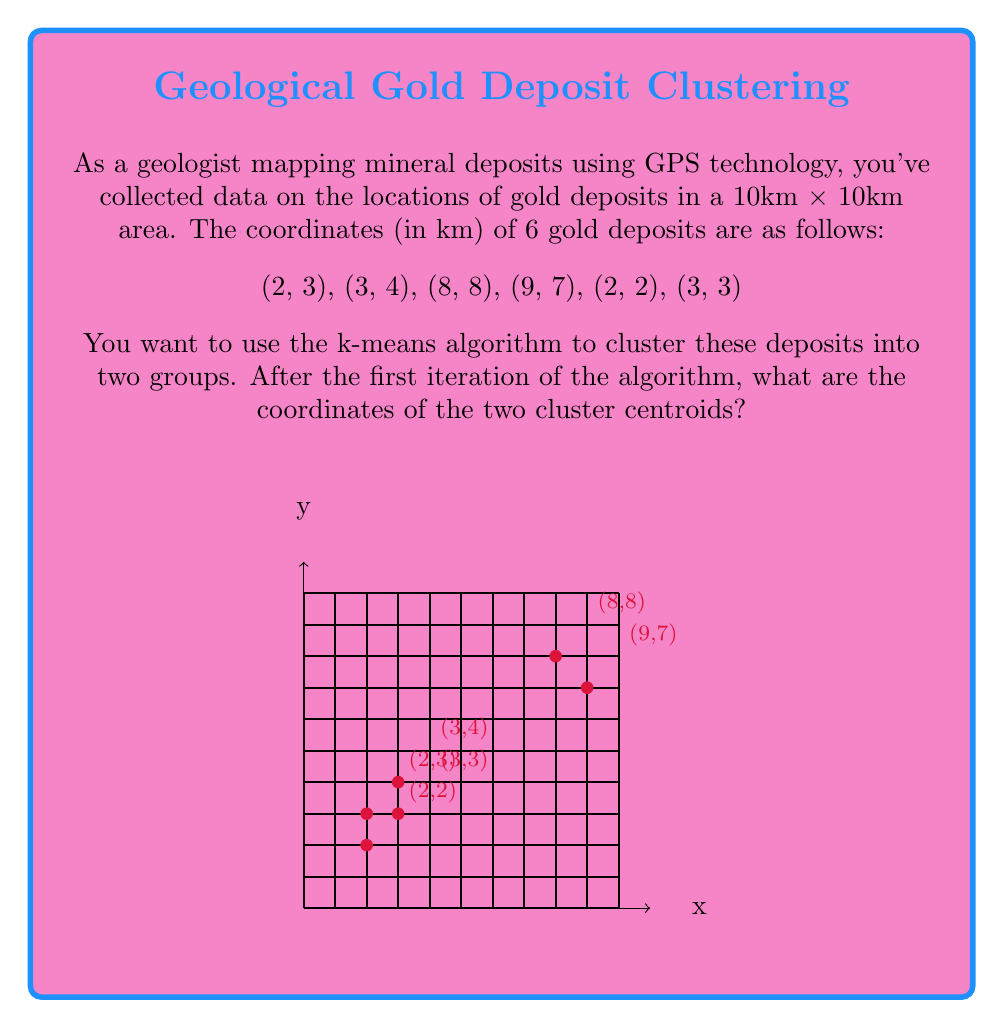Give your solution to this math problem. To solve this problem, we'll follow these steps:

1) In k-means clustering with k=2, we need to start with two initial centroids. Let's choose the first two points as our initial centroids:
   Centroid 1: (2, 3)
   Centroid 2: (3, 4)

2) Now, we need to assign each point to the nearest centroid. We'll use Euclidean distance:
   $$d = \sqrt{(x_2-x_1)^2 + (y_2-y_1)^2}$$

3) For each point, calculate the distance to both centroids:

   (2, 3): Already Centroid 1
   (3, 4): Already Centroid 2
   (8, 8): 
      To C1: $$\sqrt{(8-2)^2 + (8-3)^2} = \sqrt{61} \approx 7.81$$
      To C2: $$\sqrt{(8-3)^2 + (8-4)^2} = \sqrt{50} \approx 7.07$$ (Closer to C2)
   (9, 7):
      To C1: $$\sqrt{(9-2)^2 + (7-3)^2} = \sqrt{85} \approx 9.22$$
      To C2: $$\sqrt{(9-3)^2 + (7-4)^2} = \sqrt{61} \approx 7.81$$ (Closer to C2)
   (2, 2):
      To C1: $$\sqrt{(2-2)^2 + (2-3)^2} = 1$$
      To C2: $$\sqrt{(2-3)^2 + (2-4)^2} = \sqrt{5} \approx 2.24$$ (Closer to C1)
   (3, 3):
      To C1: $$\sqrt{(3-2)^2 + (3-3)^2} = 1$$
      To C2: $$\sqrt{(3-3)^2 + (3-4)^2} = 1$$ (Equidistant, arbitrarily assign to C1)

4) After assignment, we have:
   Cluster 1: (2, 3), (2, 2), (3, 3)
   Cluster 2: (3, 4), (8, 8), (9, 7)

5) Now, we calculate new centroids by taking the mean of all points in each cluster:

   Centroid 1: $$(\frac{2+2+3}{3}, \frac{3+2+3}{3}) = (\frac{7}{3}, \frac{8}{3}) \approx (2.33, 2.67)$$
   Centroid 2: $$(\frac{3+8+9}{3}, \frac{4+8+7}{3}) = (\frac{20}{3}, \frac{19}{3}) \approx (6.67, 6.33)$$

These are the new centroid coordinates after the first iteration of the k-means algorithm.
Answer: $(\frac{7}{3}, \frac{8}{3})$ and $(\frac{20}{3}, \frac{19}{3})$ 